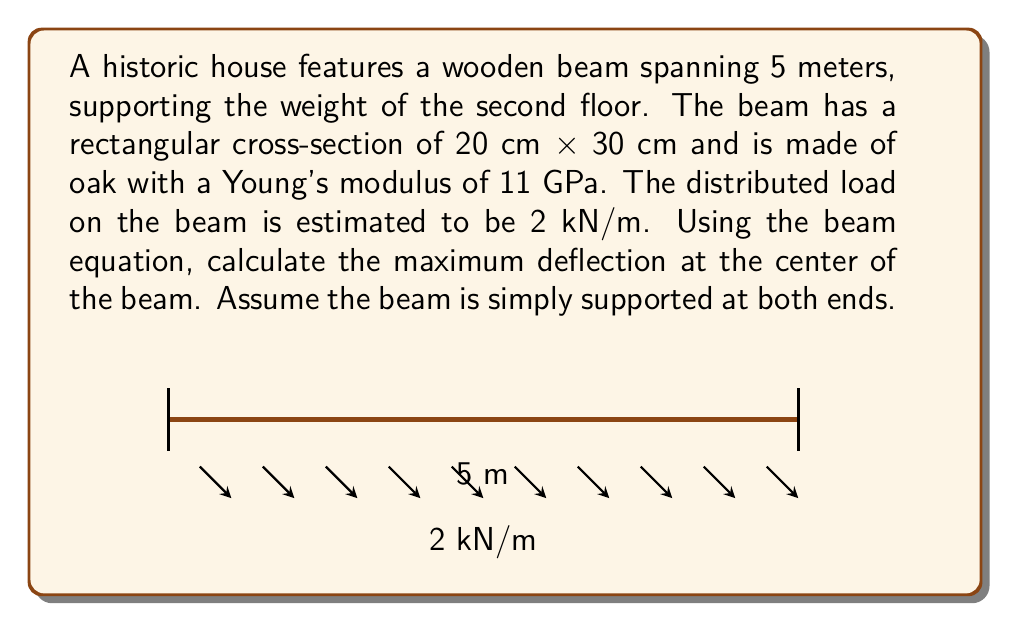Teach me how to tackle this problem. To solve this problem, we'll use the beam equation for maximum deflection of a simply supported beam with a uniformly distributed load:

$$y_{max} = \frac{5wL^4}{384EI}$$

Where:
- $y_{max}$ is the maximum deflection at the center of the beam
- $w$ is the distributed load
- $L$ is the length of the beam
- $E$ is Young's modulus
- $I$ is the moment of inertia of the beam's cross-section

Step 1: Calculate the moment of inertia $I$ for a rectangular cross-section:
$$I = \frac{bh^3}{12} = \frac{0.2 \times 0.3^3}{12} = 4.5 \times 10^{-4} \text{ m}^4$$

Step 2: Insert the given values into the beam equation:
- $w = 2 \text{ kN/m} = 2000 \text{ N/m}$
- $L = 5 \text{ m}$
- $E = 11 \text{ GPa} = 11 \times 10^9 \text{ Pa}$
- $I = 4.5 \times 10^{-4} \text{ m}^4$

$$y_{max} = \frac{5 \times 2000 \times 5^4}{384 \times 11 \times 10^9 \times 4.5 \times 10^{-4}}$$

Step 3: Calculate the result:
$$y_{max} = 0.00295 \text{ m} = 2.95 \text{ mm}$$

This deflection is relatively small compared to the beam's length, indicating that the beam is likely structurally sound. However, for a complete assessment, this result should be compared with allowable deflection limits for historic structures.
Answer: 2.95 mm 